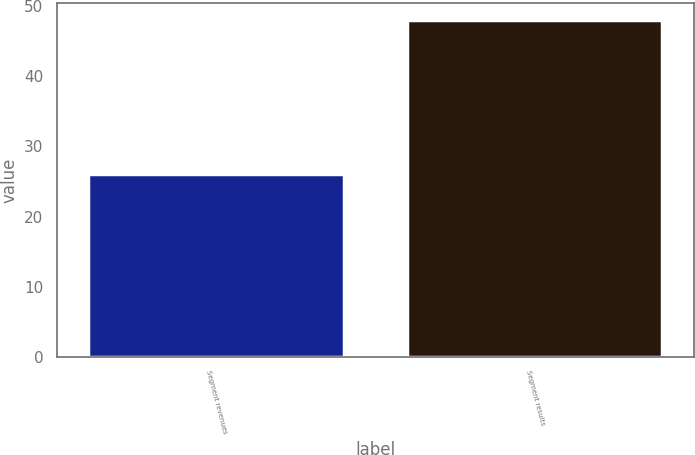<chart> <loc_0><loc_0><loc_500><loc_500><bar_chart><fcel>Segment revenues<fcel>Segment results<nl><fcel>26<fcel>48<nl></chart> 